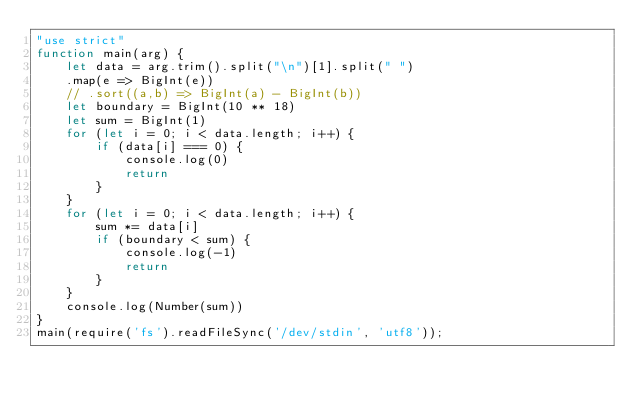<code> <loc_0><loc_0><loc_500><loc_500><_JavaScript_>"use strict"
function main(arg) {
    let data = arg.trim().split("\n")[1].split(" ")
    .map(e => BigInt(e))
    // .sort((a,b) => BigInt(a) - BigInt(b))
    let boundary = BigInt(10 ** 18)
    let sum = BigInt(1)
    for (let i = 0; i < data.length; i++) {
        if (data[i] === 0) {
            console.log(0)
            return
        }
    }
    for (let i = 0; i < data.length; i++) {
        sum *= data[i]
        if (boundary < sum) {
            console.log(-1)
            return
        }
    }
    console.log(Number(sum))
}
main(require('fs').readFileSync('/dev/stdin', 'utf8'));
</code> 